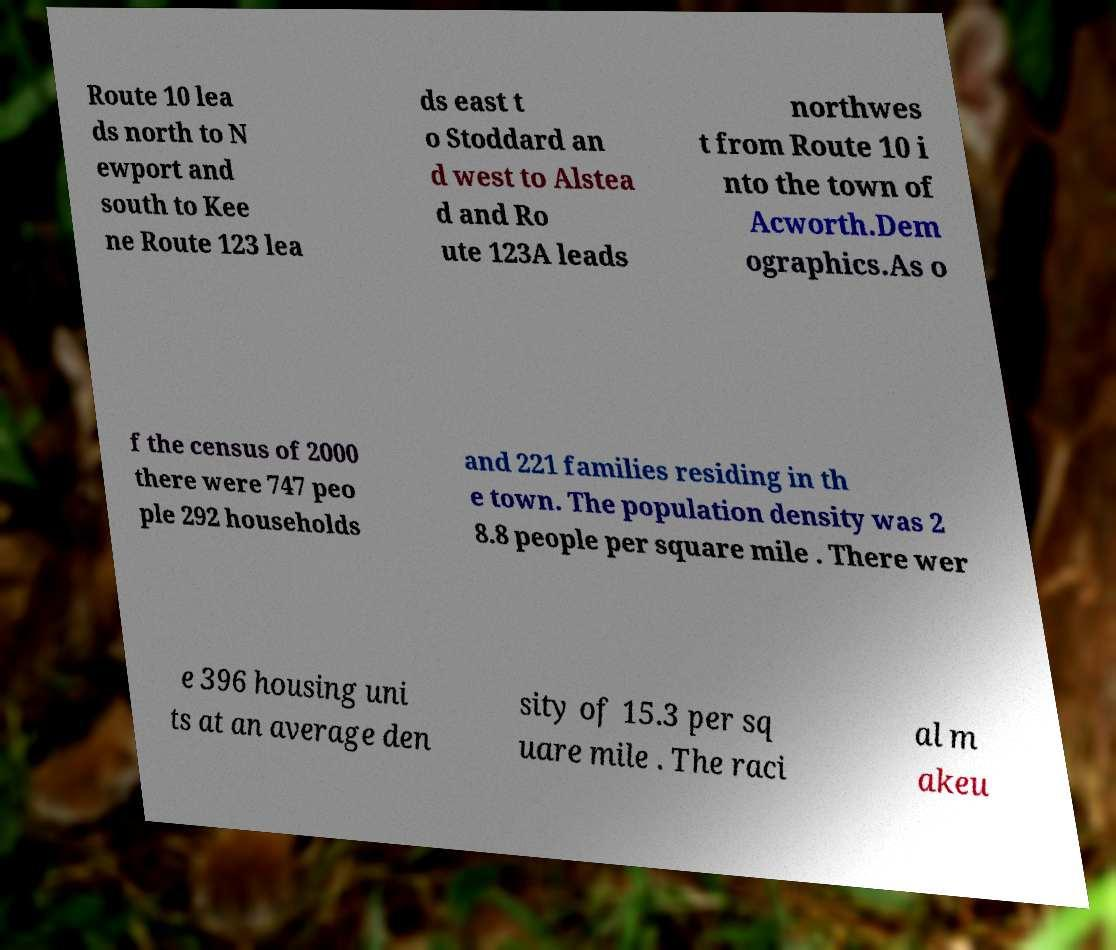Can you accurately transcribe the text from the provided image for me? Route 10 lea ds north to N ewport and south to Kee ne Route 123 lea ds east t o Stoddard an d west to Alstea d and Ro ute 123A leads northwes t from Route 10 i nto the town of Acworth.Dem ographics.As o f the census of 2000 there were 747 peo ple 292 households and 221 families residing in th e town. The population density was 2 8.8 people per square mile . There wer e 396 housing uni ts at an average den sity of 15.3 per sq uare mile . The raci al m akeu 